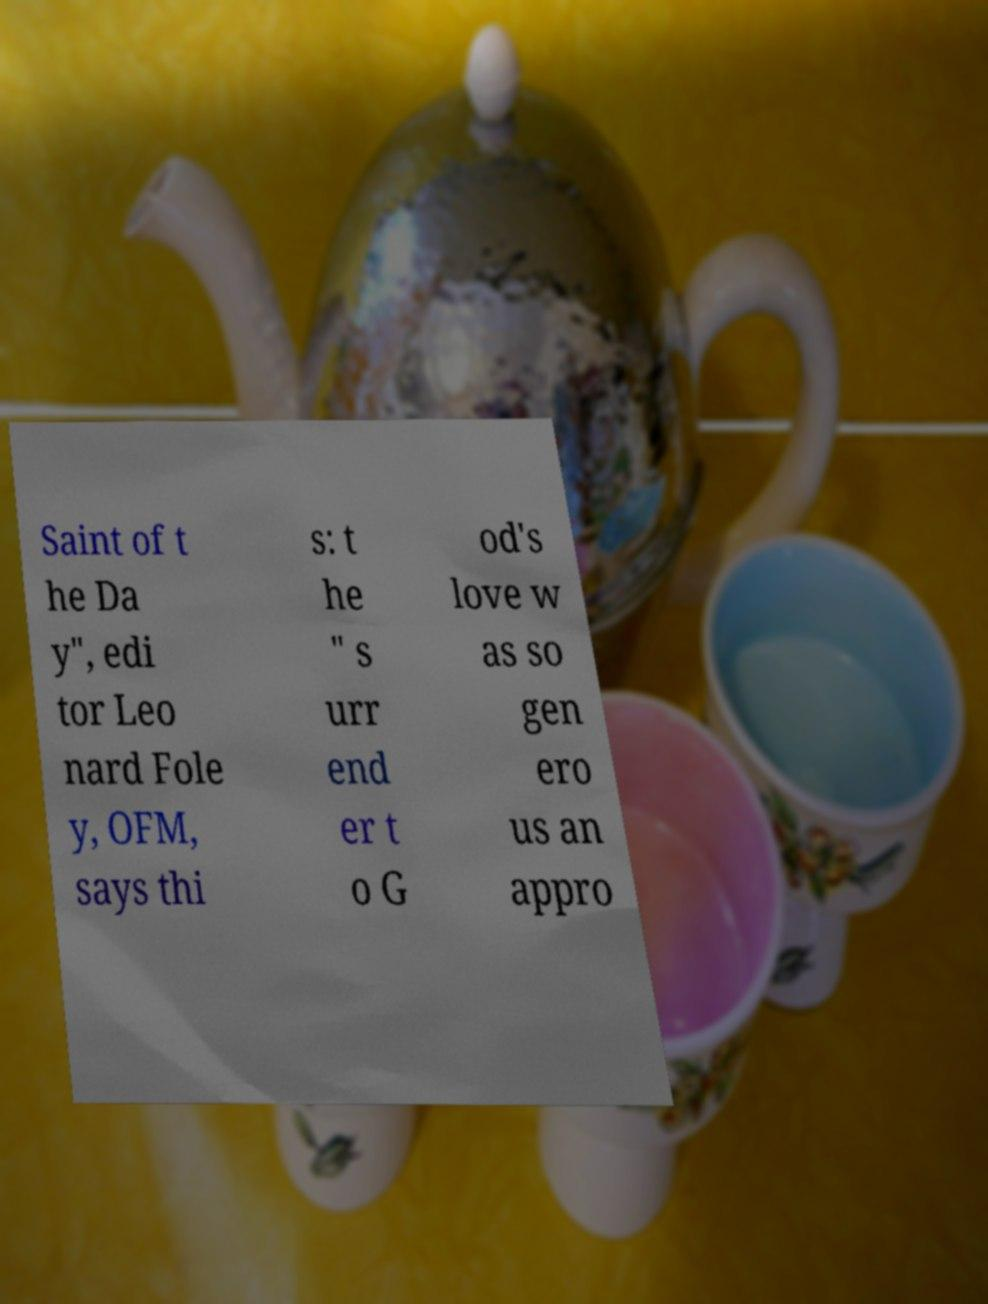Can you accurately transcribe the text from the provided image for me? Saint of t he Da y", edi tor Leo nard Fole y, OFM, says thi s: t he " s urr end er t o G od's love w as so gen ero us an appro 